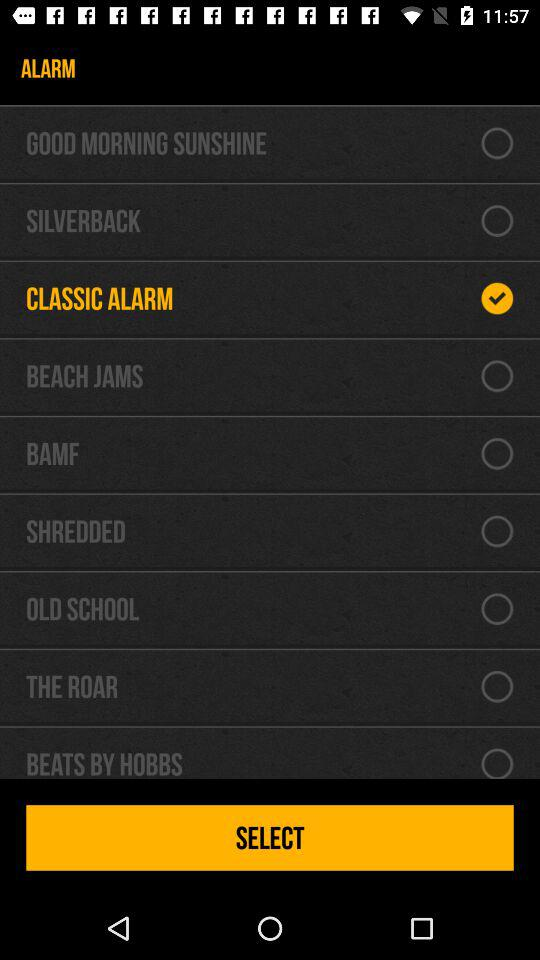What are the alarm tones that I can select? The alarm tones that you can select are "GOOD MORNING SUNSHINE", "SILVERBACK", "BEACH JAMS", "SHREDDED", "OLD SCHOOL", "THE ROAR" and "BEATS BY HOBBS". 